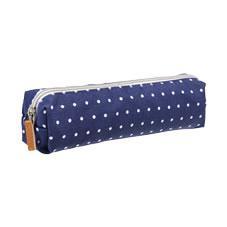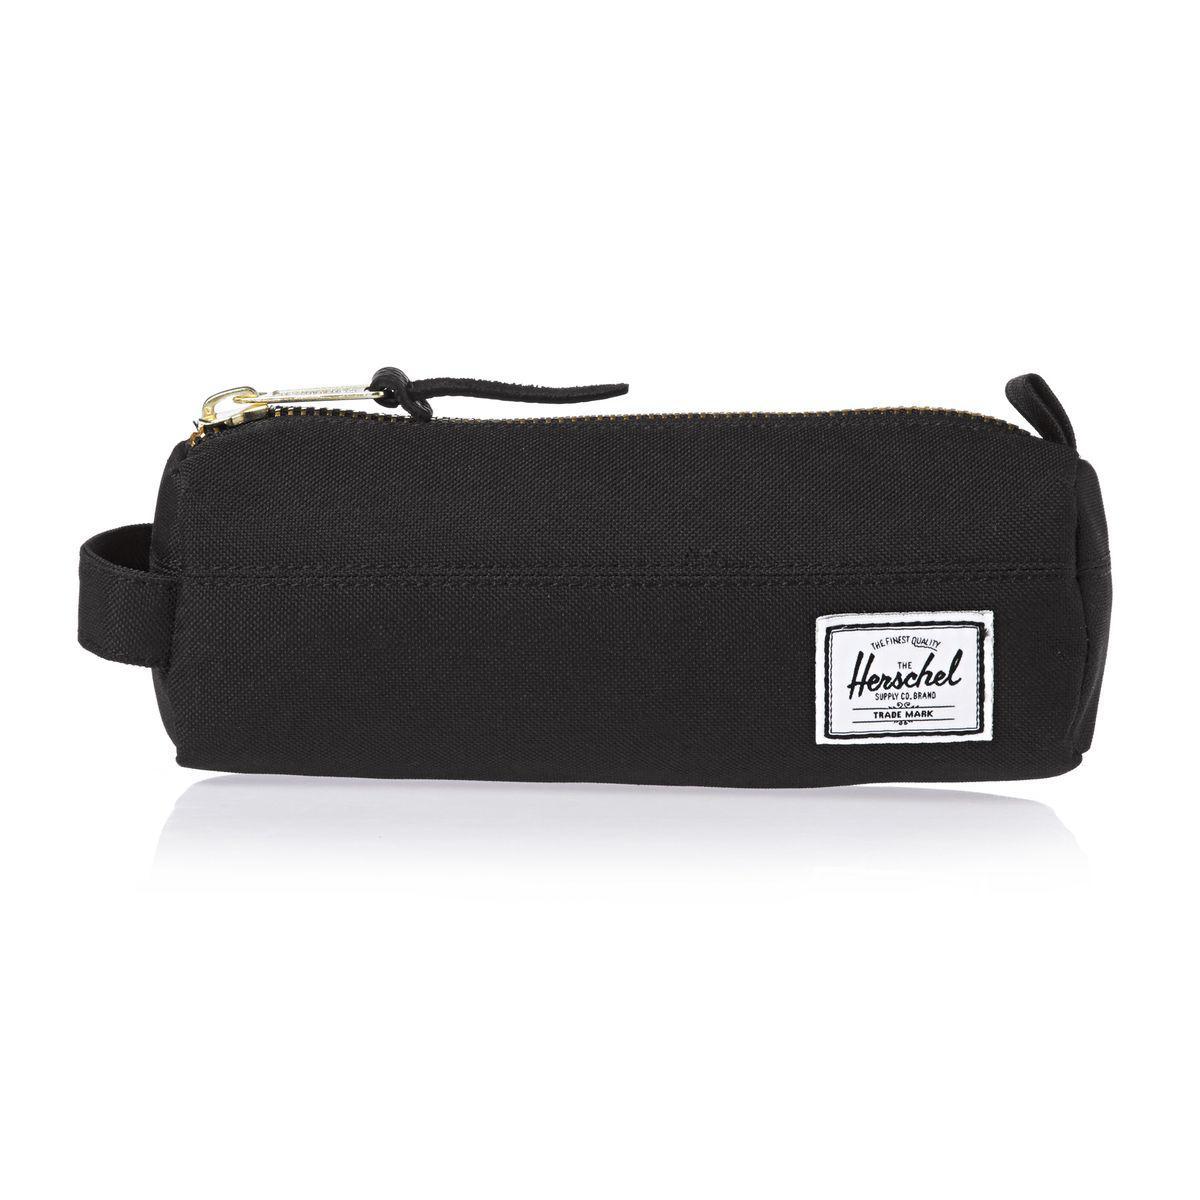The first image is the image on the left, the second image is the image on the right. For the images displayed, is the sentence "One of the images shows a blue bag with white polka dots." factually correct? Answer yes or no. Yes. 